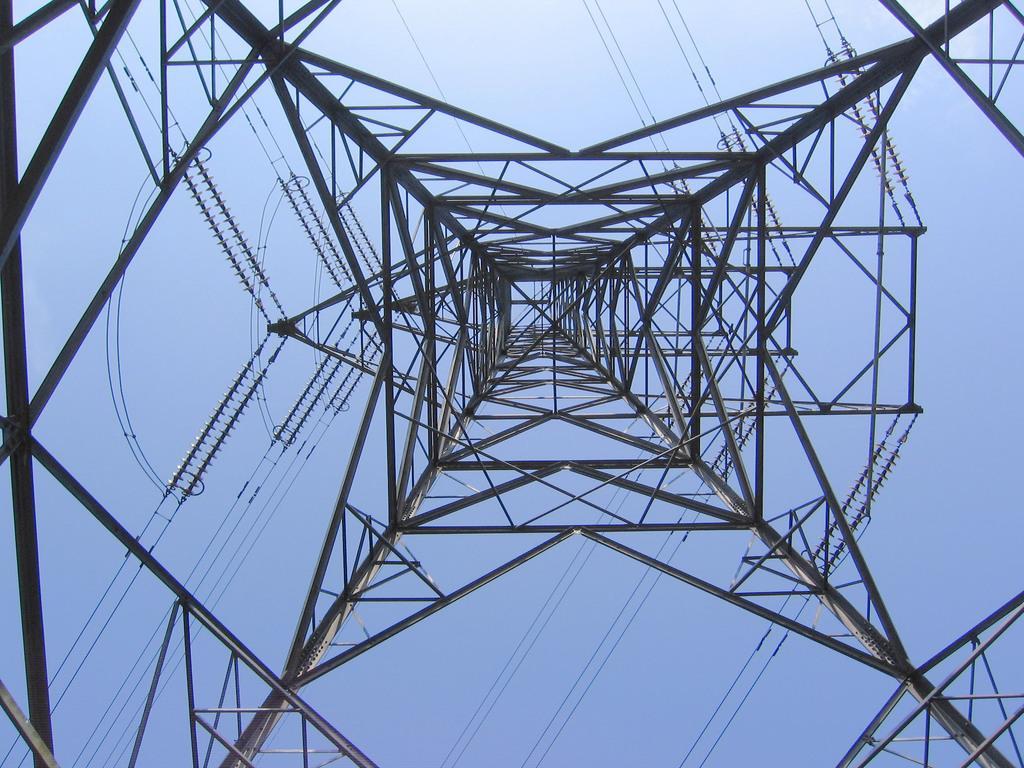Can you describe this image briefly? In this picture we can see a tower and the sky in the background. 